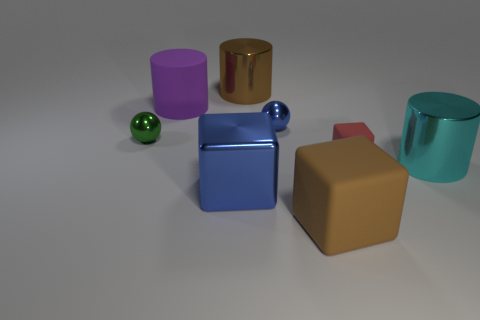Subtract all cyan cylinders. Subtract all red spheres. How many cylinders are left? 2 Subtract all red spheres. How many brown cylinders are left? 1 Add 3 large purples. How many big browns exist? 0 Subtract all large metal cylinders. Subtract all brown things. How many objects are left? 4 Add 2 big purple matte cylinders. How many big purple matte cylinders are left? 3 Add 8 small yellow blocks. How many small yellow blocks exist? 8 Add 1 large blue metallic objects. How many objects exist? 9 Subtract all green spheres. How many spheres are left? 1 Subtract all big rubber cylinders. How many cylinders are left? 2 Subtract 0 gray cylinders. How many objects are left? 8 